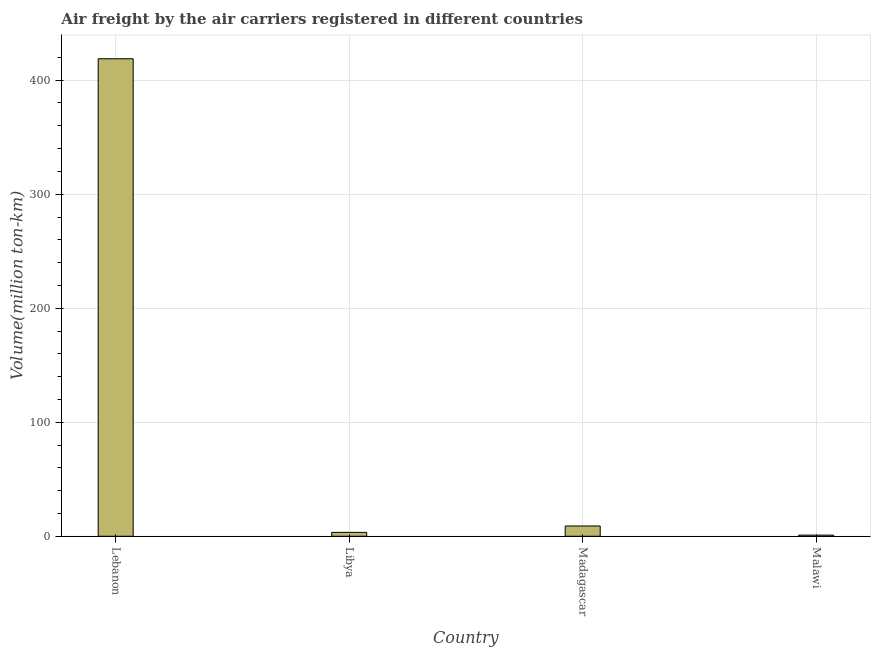Does the graph contain any zero values?
Your response must be concise. No. What is the title of the graph?
Provide a succinct answer. Air freight by the air carriers registered in different countries. What is the label or title of the Y-axis?
Provide a succinct answer. Volume(million ton-km). Across all countries, what is the maximum air freight?
Provide a short and direct response. 418.8. In which country was the air freight maximum?
Make the answer very short. Lebanon. In which country was the air freight minimum?
Provide a short and direct response. Malawi. What is the sum of the air freight?
Your answer should be compact. 432.2. What is the average air freight per country?
Provide a succinct answer. 108.05. What is the median air freight?
Offer a very short reply. 6.2. In how many countries, is the air freight greater than 60 million ton-km?
Provide a succinct answer. 1. What is the ratio of the air freight in Lebanon to that in Madagascar?
Your response must be concise. 46.53. Is the air freight in Lebanon less than that in Malawi?
Your answer should be very brief. No. What is the difference between the highest and the second highest air freight?
Your response must be concise. 409.8. What is the difference between the highest and the lowest air freight?
Give a very brief answer. 417.8. How many bars are there?
Make the answer very short. 4. Are all the bars in the graph horizontal?
Give a very brief answer. No. How many countries are there in the graph?
Offer a terse response. 4. Are the values on the major ticks of Y-axis written in scientific E-notation?
Your response must be concise. No. What is the Volume(million ton-km) in Lebanon?
Provide a succinct answer. 418.8. What is the Volume(million ton-km) of Libya?
Keep it short and to the point. 3.4. What is the Volume(million ton-km) of Madagascar?
Your response must be concise. 9. What is the Volume(million ton-km) in Malawi?
Provide a short and direct response. 1. What is the difference between the Volume(million ton-km) in Lebanon and Libya?
Ensure brevity in your answer.  415.4. What is the difference between the Volume(million ton-km) in Lebanon and Madagascar?
Your answer should be very brief. 409.8. What is the difference between the Volume(million ton-km) in Lebanon and Malawi?
Make the answer very short. 417.8. What is the difference between the Volume(million ton-km) in Libya and Madagascar?
Provide a short and direct response. -5.6. What is the difference between the Volume(million ton-km) in Libya and Malawi?
Provide a short and direct response. 2.4. What is the ratio of the Volume(million ton-km) in Lebanon to that in Libya?
Your response must be concise. 123.18. What is the ratio of the Volume(million ton-km) in Lebanon to that in Madagascar?
Provide a short and direct response. 46.53. What is the ratio of the Volume(million ton-km) in Lebanon to that in Malawi?
Your response must be concise. 418.8. What is the ratio of the Volume(million ton-km) in Libya to that in Madagascar?
Make the answer very short. 0.38. 